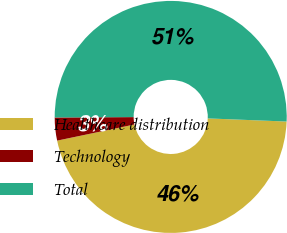Convert chart. <chart><loc_0><loc_0><loc_500><loc_500><pie_chart><fcel>Healthcare distribution<fcel>Technology<fcel>Total<nl><fcel>46.1%<fcel>3.2%<fcel>50.71%<nl></chart> 